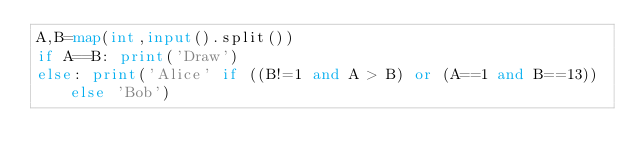<code> <loc_0><loc_0><loc_500><loc_500><_Python_>A,B=map(int,input().split())
if A==B: print('Draw')
else: print('Alice' if ((B!=1 and A > B) or (A==1 and B==13)) else 'Bob')</code> 